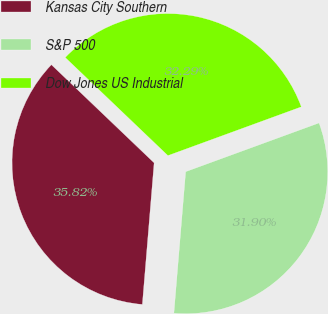<chart> <loc_0><loc_0><loc_500><loc_500><pie_chart><fcel>Kansas City Southern<fcel>S&P 500<fcel>Dow Jones US Industrial<nl><fcel>35.82%<fcel>31.9%<fcel>32.29%<nl></chart> 